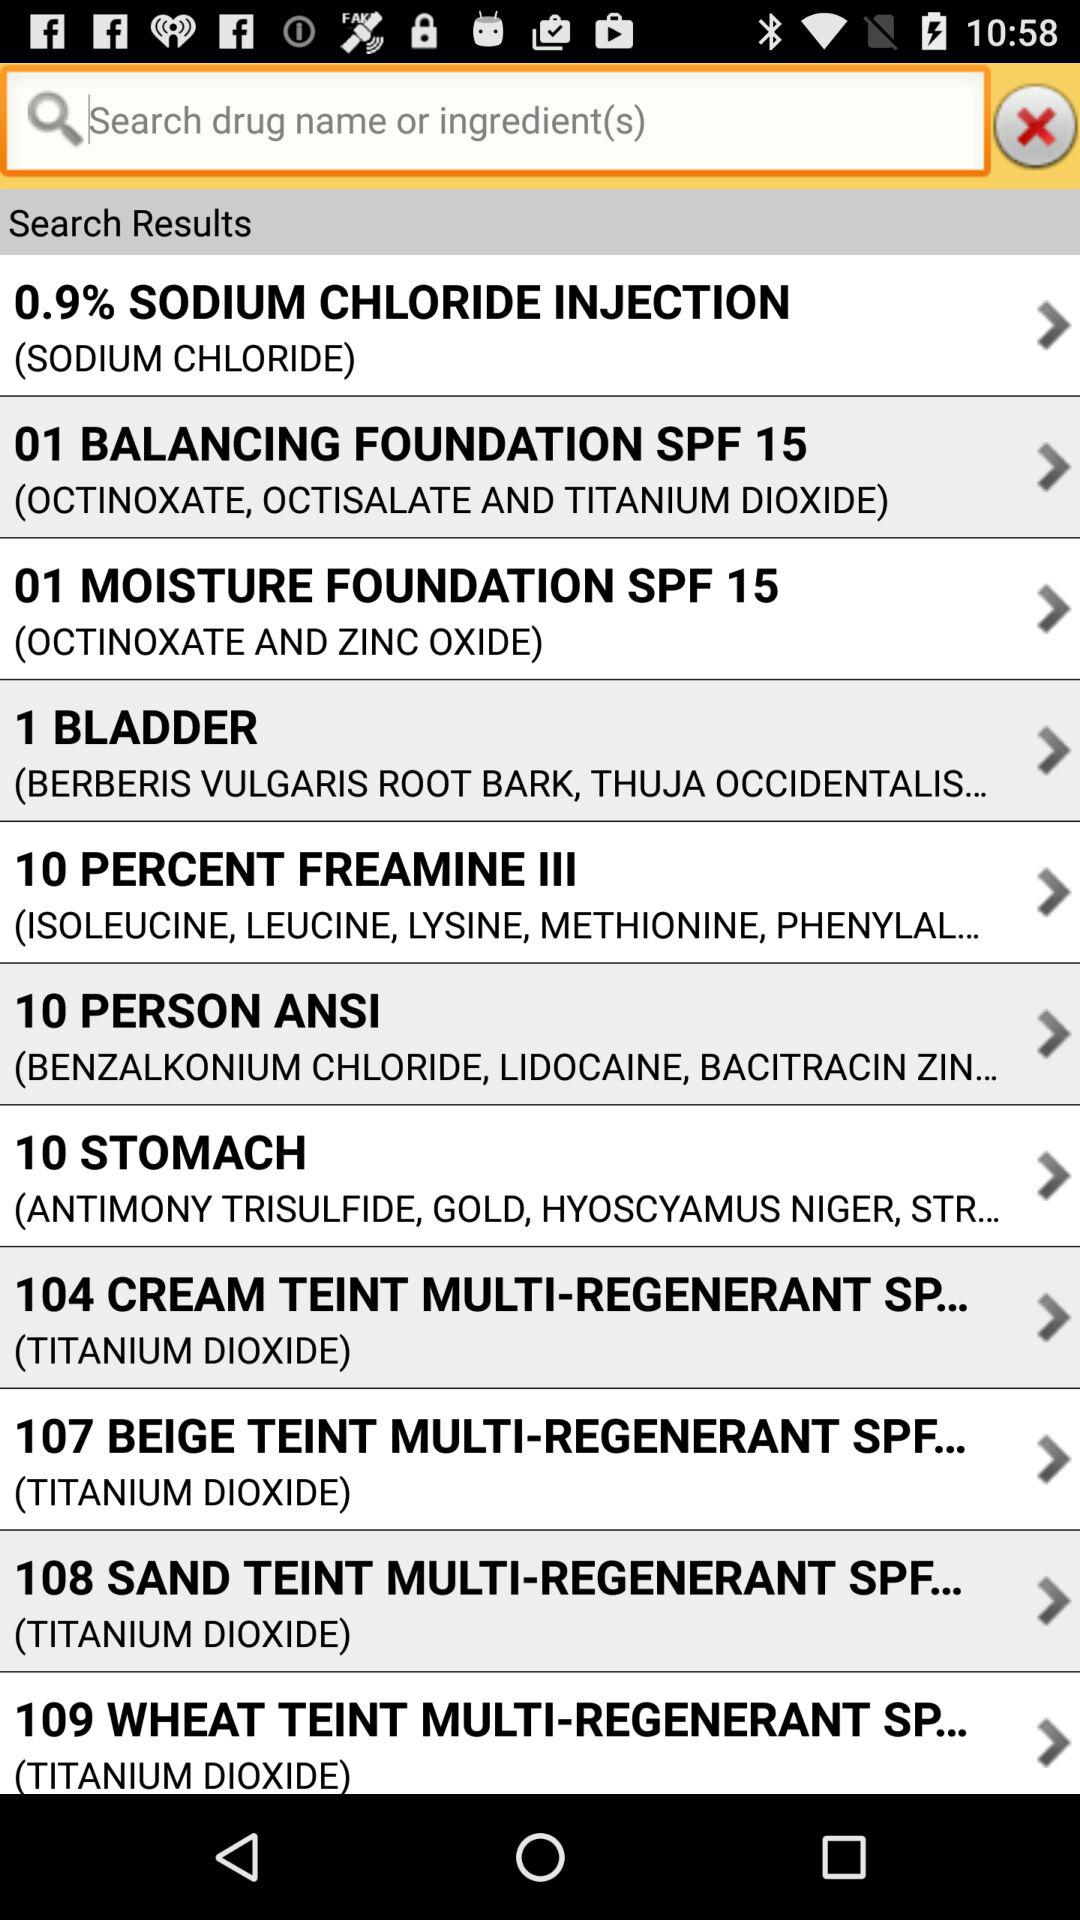What are the ingredients in "01 MOISTURE FOUNDATION SPF 15"? The ingredients are octinoxate and zinc oxide. 